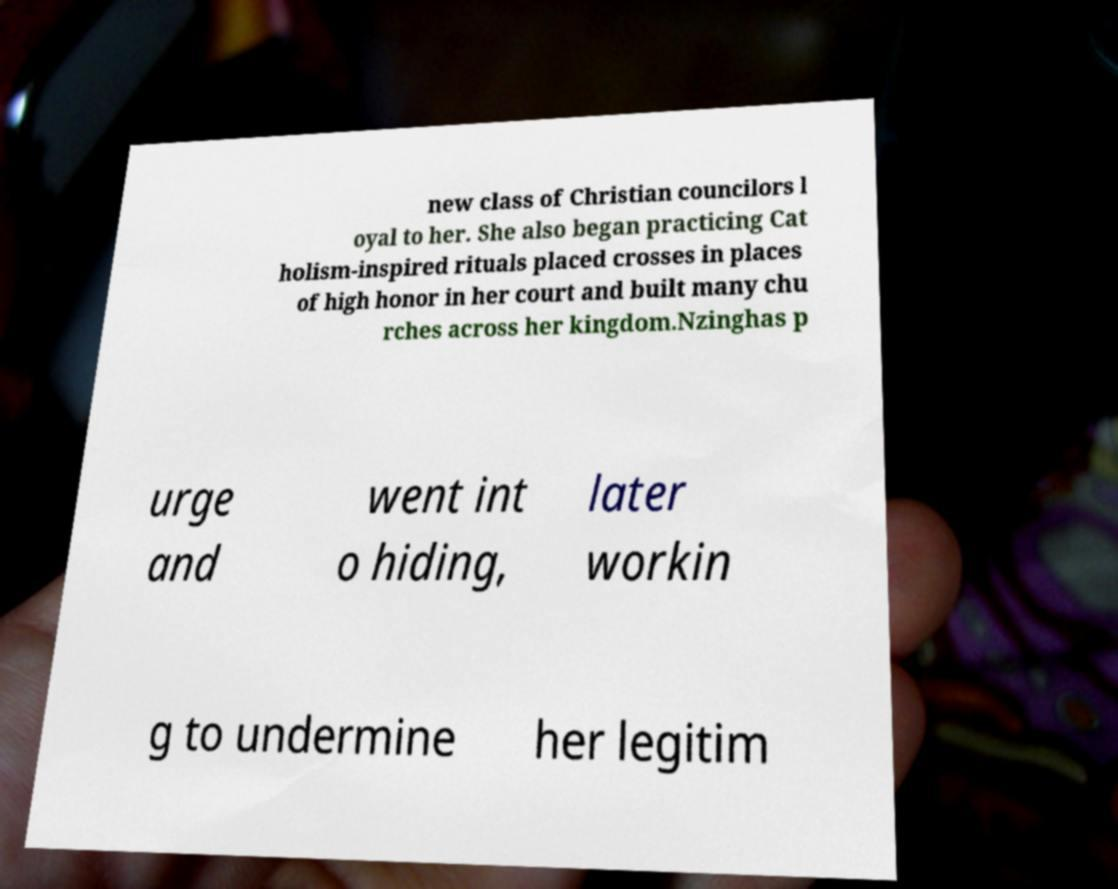Can you accurately transcribe the text from the provided image for me? new class of Christian councilors l oyal to her. She also began practicing Cat holism-inspired rituals placed crosses in places of high honor in her court and built many chu rches across her kingdom.Nzinghas p urge and went int o hiding, later workin g to undermine her legitim 